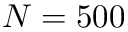<formula> <loc_0><loc_0><loc_500><loc_500>N = 5 0 0</formula> 